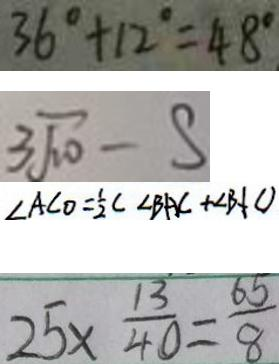<formula> <loc_0><loc_0><loc_500><loc_500>3 6 ^ { \circ } + 1 2 ^ { \circ } = 4 8 ^ { \circ } 
 3 \sqrt { 1 0 } - S 
 \angle A C O = \frac { 1 } { 2 } C \angle B A C + \angle B C O 
 2 5 \times \frac { 1 3 } { 4 0 } = \frac { 6 5 } { 8 }</formula> 